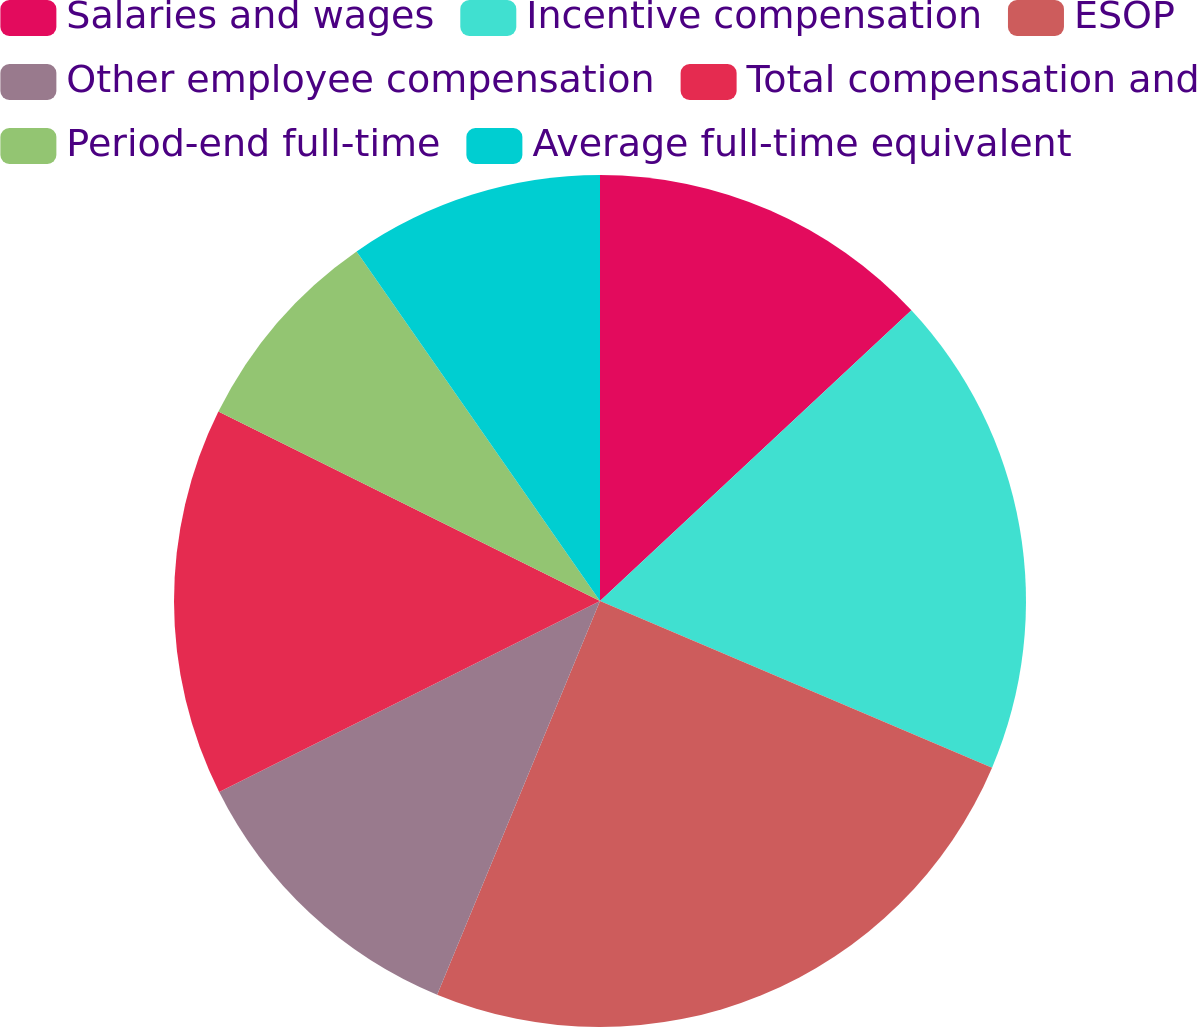<chart> <loc_0><loc_0><loc_500><loc_500><pie_chart><fcel>Salaries and wages<fcel>Incentive compensation<fcel>ESOP<fcel>Other employee compensation<fcel>Total compensation and<fcel>Period-end full-time<fcel>Average full-time equivalent<nl><fcel>13.05%<fcel>18.35%<fcel>24.85%<fcel>11.36%<fcel>14.73%<fcel>7.99%<fcel>9.68%<nl></chart> 